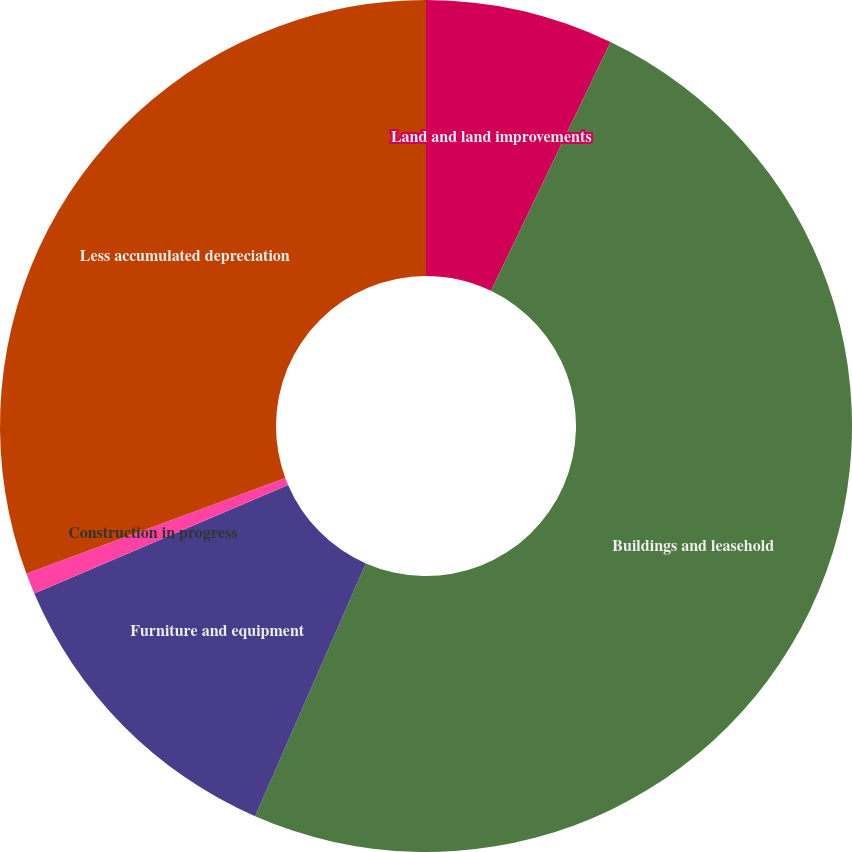Convert chart to OTSL. <chart><loc_0><loc_0><loc_500><loc_500><pie_chart><fcel>Land and land improvements<fcel>Buildings and leasehold<fcel>Furniture and equipment<fcel>Construction in progress<fcel>Less accumulated depreciation<nl><fcel>7.13%<fcel>49.44%<fcel>12.0%<fcel>0.8%<fcel>30.63%<nl></chart> 